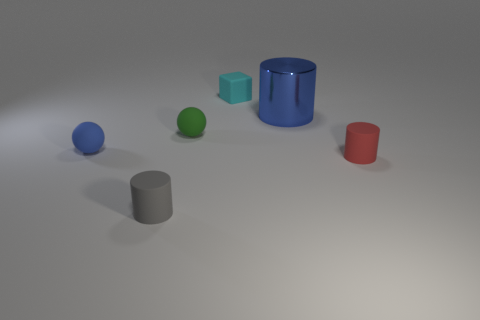Is there anything else that has the same material as the big blue object?
Offer a terse response. No. Do the small cube to the right of the small gray matte thing and the tiny object that is in front of the red object have the same color?
Offer a terse response. No. How big is the cyan thing?
Offer a terse response. Small. What is the size of the sphere that is in front of the green thing?
Give a very brief answer. Small. There is a thing that is behind the tiny green ball and to the right of the cyan object; what shape is it?
Your answer should be very brief. Cylinder. What number of other objects are the same shape as the small cyan thing?
Offer a terse response. 0. What is the color of the rubber block that is the same size as the red matte thing?
Ensure brevity in your answer.  Cyan. How many objects are either green cylinders or objects?
Provide a succinct answer. 6. There is a large blue cylinder; are there any blue objects behind it?
Make the answer very short. No. Is there a tiny brown ball made of the same material as the small red thing?
Your answer should be compact. No. 